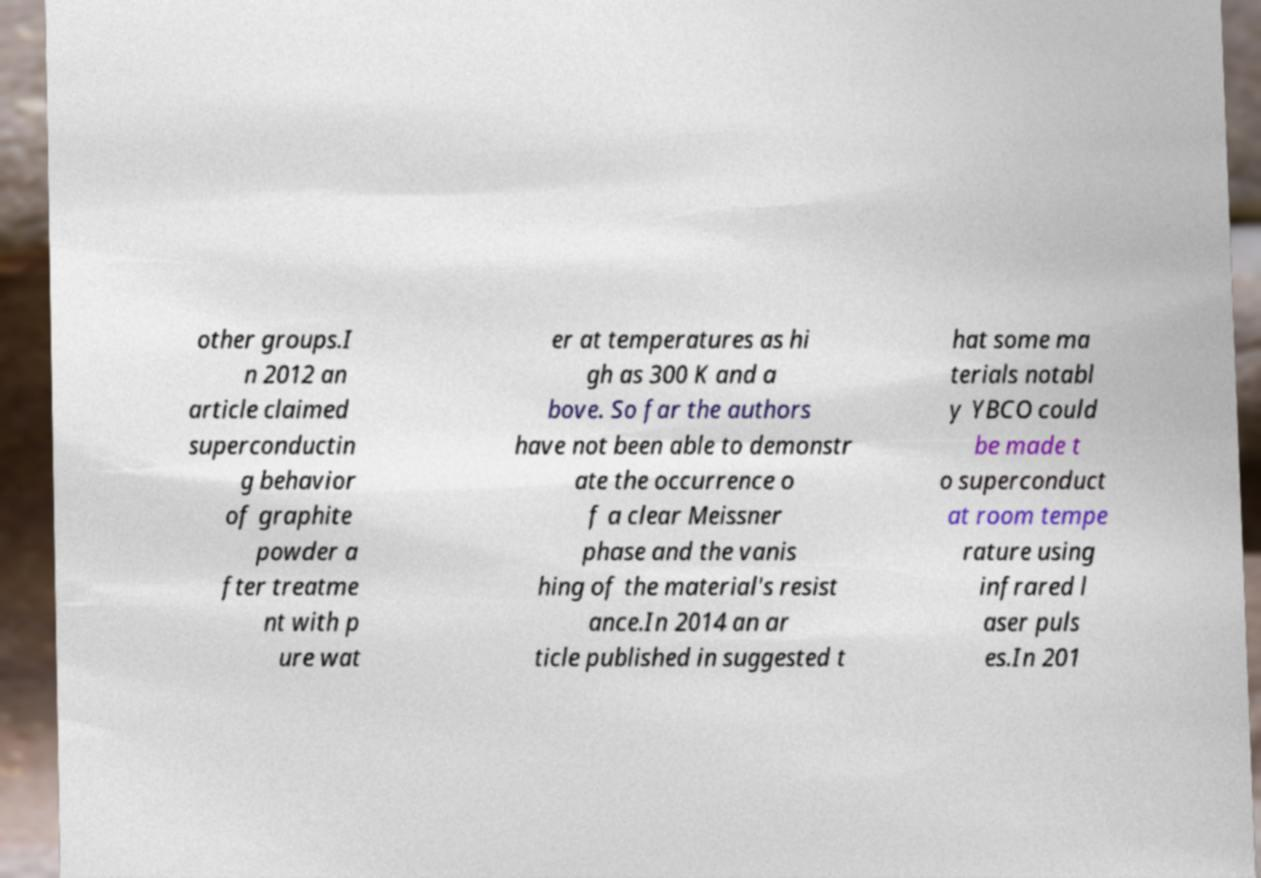Can you accurately transcribe the text from the provided image for me? other groups.I n 2012 an article claimed superconductin g behavior of graphite powder a fter treatme nt with p ure wat er at temperatures as hi gh as 300 K and a bove. So far the authors have not been able to demonstr ate the occurrence o f a clear Meissner phase and the vanis hing of the material's resist ance.In 2014 an ar ticle published in suggested t hat some ma terials notabl y YBCO could be made t o superconduct at room tempe rature using infrared l aser puls es.In 201 